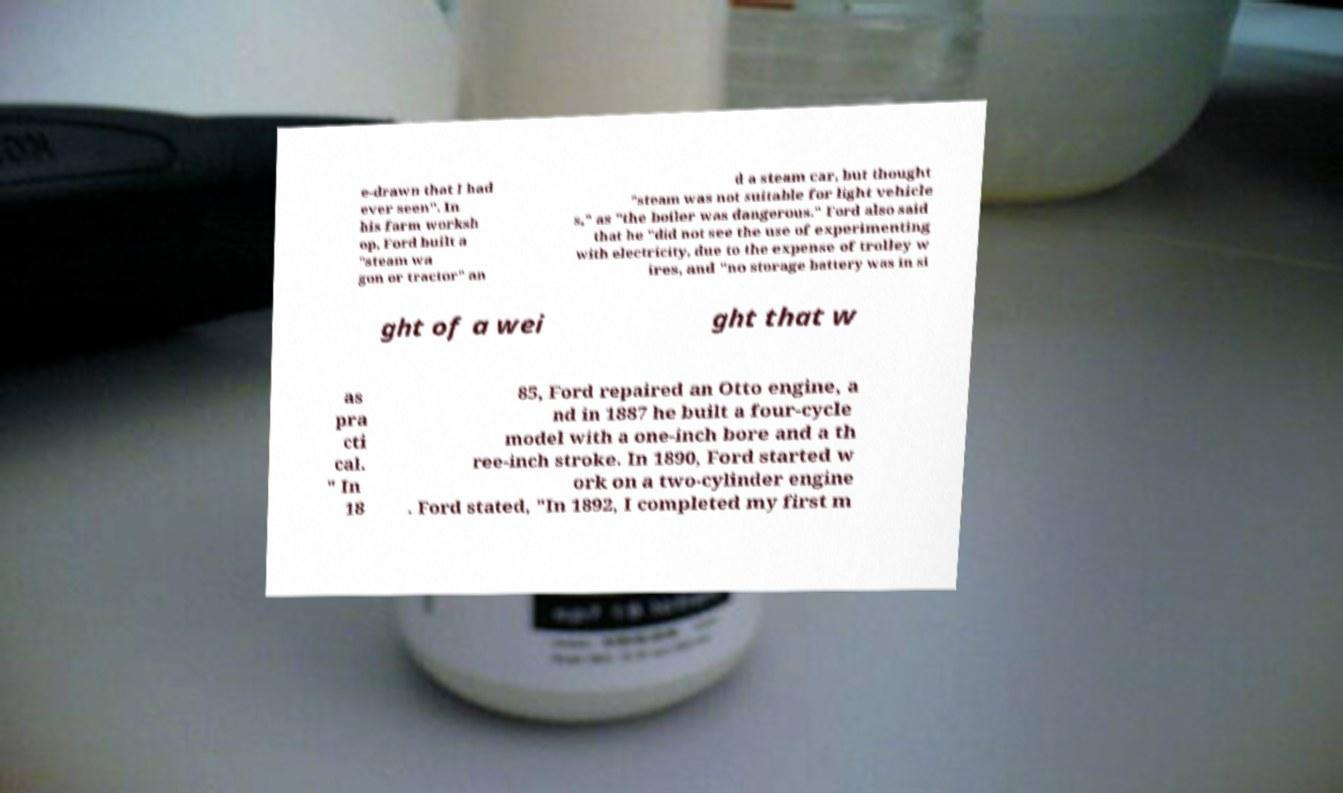Could you extract and type out the text from this image? e-drawn that I had ever seen". In his farm worksh op, Ford built a "steam wa gon or tractor" an d a steam car, but thought "steam was not suitable for light vehicle s," as "the boiler was dangerous." Ford also said that he "did not see the use of experimenting with electricity, due to the expense of trolley w ires, and "no storage battery was in si ght of a wei ght that w as pra cti cal. " In 18 85, Ford repaired an Otto engine, a nd in 1887 he built a four-cycle model with a one-inch bore and a th ree-inch stroke. In 1890, Ford started w ork on a two-cylinder engine . Ford stated, "In 1892, I completed my first m 